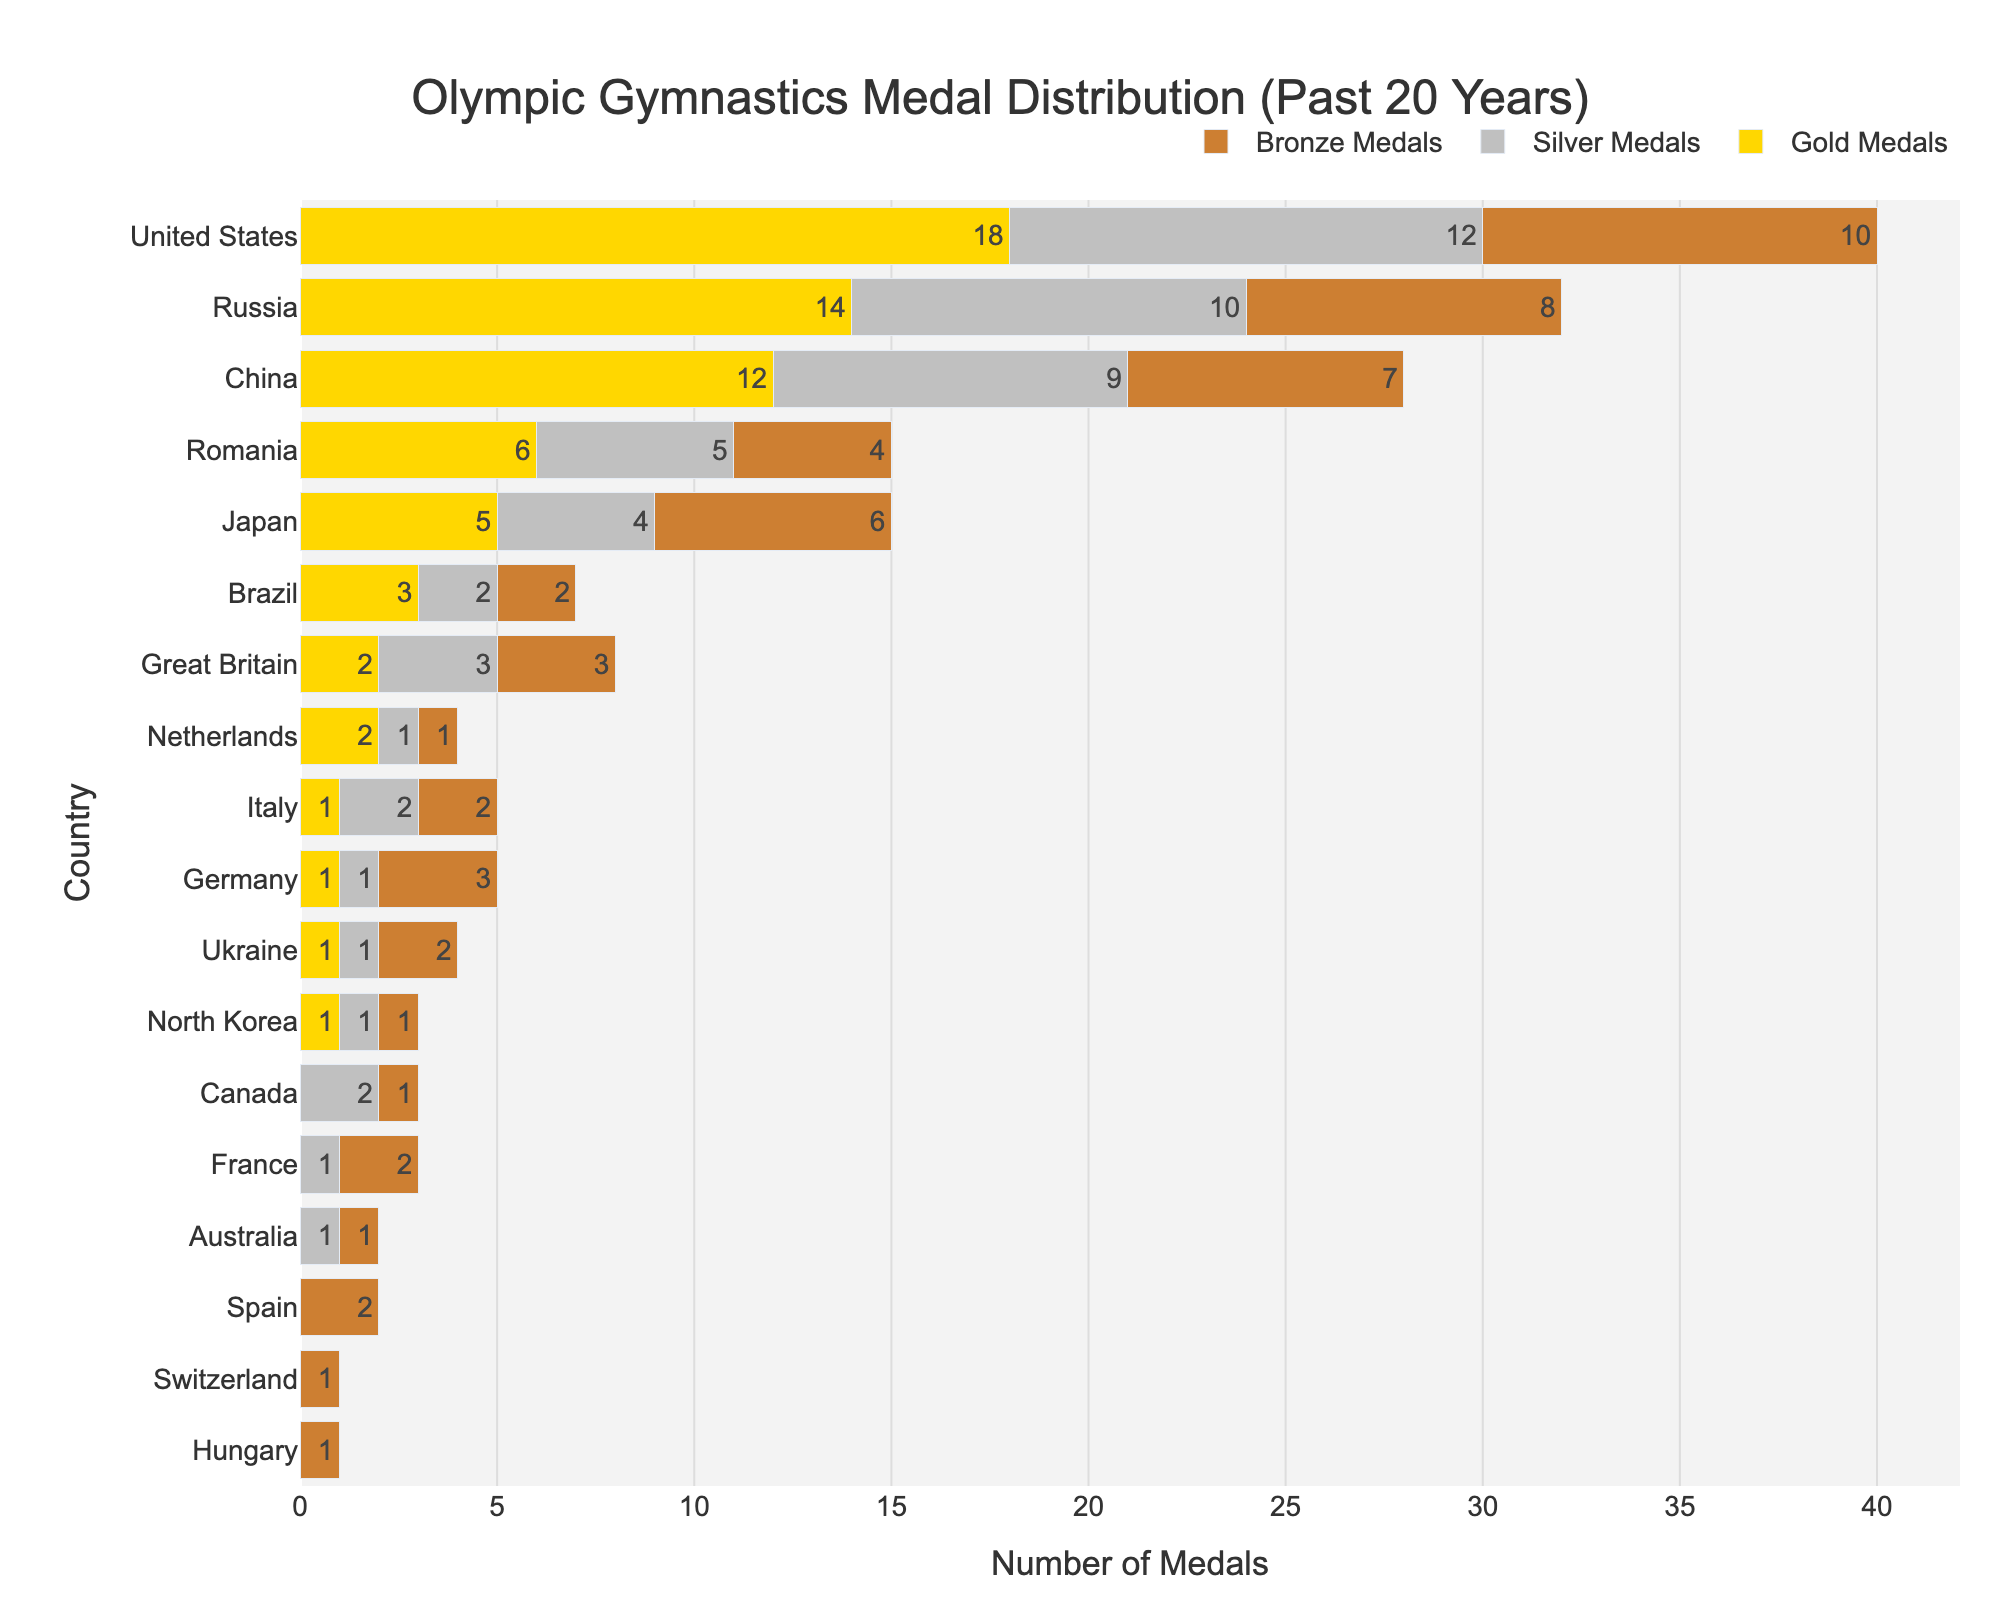Which country has won the most gold medals? The longest gold bar represents the country with the most gold medals. The United States has the longest gold bar with 18 gold medals.
Answer: United States Which country has the fewest medals in total? Add up the gold, silver, and bronze medals for each country. Switzerland and Hungary both have the shortest bars and have the least medals in total, each with 1.
Answer: Switzerland, Hungary How many more gold medals has the United States won compared to Japan? Refer to the gold medals bars for both countries. The United States has won 18 gold medals and Japan has won 5. Subtract 5 from 18.
Answer: 13 Which countries have won exactly the same number of gold medals? Compare the lengths of gold medal bars. Both Great Britain and Netherlands have bars with 2 gold medals.
Answer: Great Britain, Netherlands How many total medals has Brazil won? Add the gold, silver, and bronze medals for Brazil. Brazil has 3 gold, 2 silver, and 2 bronze medals. 3 + 2 + 2 = 7.
Answer: 7 Which country has the highest count of bronze medals, and how many do they have? Identify the longest bronze bar. Japan has the highest count with 6 bronze medals.
Answer: Japan How many silver medals has Germany won? Check the length of the silver medal bar for Germany. Germany has won 1 silver medal.
Answer: 1 Which country has the second-most total medals? Sum the gold, silver, and bronze medals for each country and compare. Russia has 14 gold, 10 silver, and 8 bronze medals, totaling 32, the second-highest.
Answer: Russia How many more total medals does Russia have compared to China? Calculate the total medals (gold + silver + bronze) for both countries and subtract China's total from Russia's total. Russia has 32 and China has 28. 32 - 28 = 4.
Answer: 4 What are the total number of medals won by European countries combined? Sum the medals for Romania, Great Britain, Netherlands, Italy, Germany, Ukraine, France, Switzerland, and Hungary.  (6+5+4)+(2+3+3)+(2+1+1)+(1+2+2)+(1+1+3)+(1+1+2)+(0+1+2)+(0+0+1)+(0+0+1) = 46
Answer: 46 